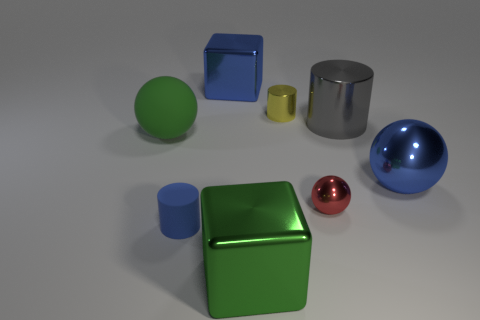Add 1 large green balls. How many objects exist? 9 Subtract all spheres. How many objects are left? 5 Add 7 tiny blue rubber cylinders. How many tiny blue rubber cylinders are left? 8 Add 6 big cubes. How many big cubes exist? 8 Subtract 0 gray blocks. How many objects are left? 8 Subtract all small spheres. Subtract all big green metal things. How many objects are left? 6 